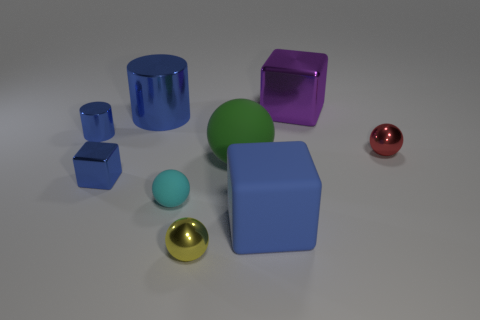If I needed to use one of these objects as a paperweight, which one would be best suited for the task? The large blue cube or the purple cube, due to their larger size and more substantial weight, would be the most effective as paperweights. 